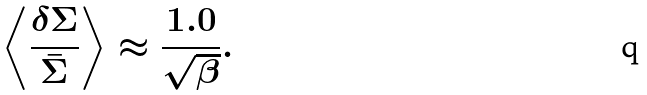<formula> <loc_0><loc_0><loc_500><loc_500>\left \langle \frac { \delta \Sigma } { \bar { \Sigma } } \right \rangle \approx \frac { 1 . 0 } { \sqrt { \beta } } .</formula> 